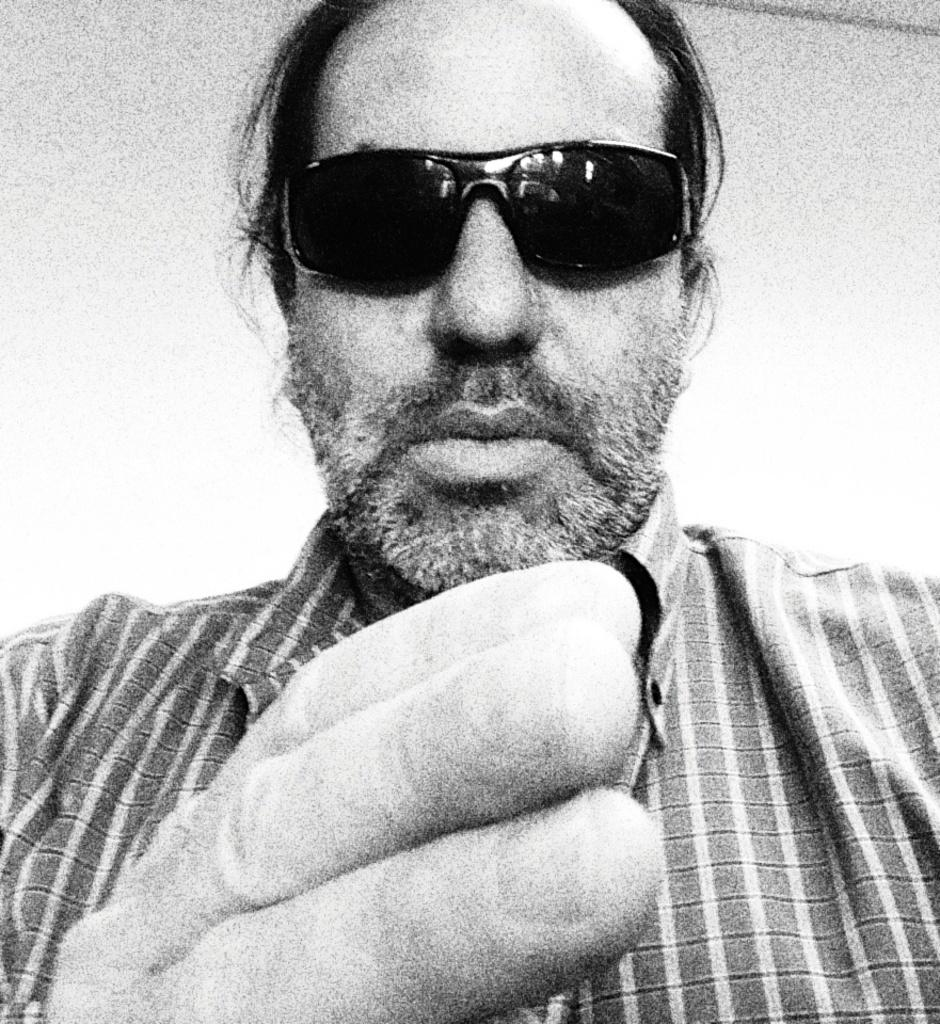Who is present in the image? There is a man in the image. What is the man wearing in the image? The man is wearing sunglasses. What is the color scheme of the image? The image is black and white. What type of soap is the man using in the image? There is no soap present in the image, as it is a black and white image of a man wearing sunglasses. 